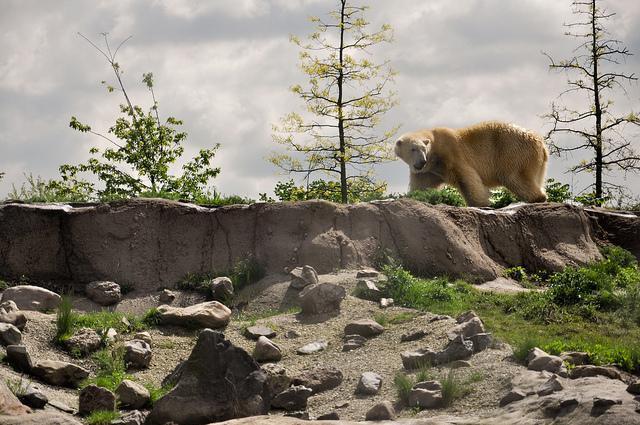How many people are looking at the camera?
Give a very brief answer. 0. 